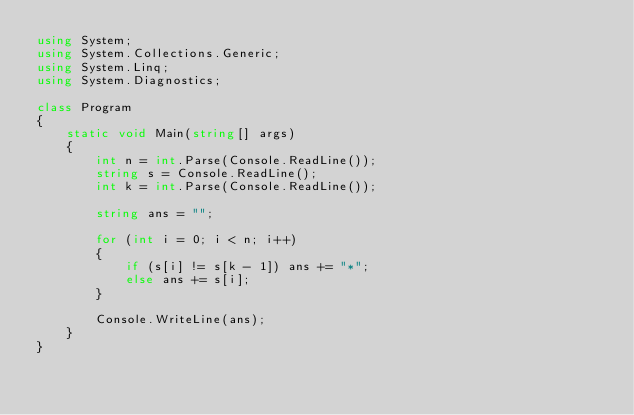<code> <loc_0><loc_0><loc_500><loc_500><_C#_>using System;
using System.Collections.Generic;
using System.Linq;
using System.Diagnostics;

class Program
{
    static void Main(string[] args)
    {
        int n = int.Parse(Console.ReadLine());
        string s = Console.ReadLine();
        int k = int.Parse(Console.ReadLine());

        string ans = "";

        for (int i = 0; i < n; i++)
        {
            if (s[i] != s[k - 1]) ans += "*";
            else ans += s[i];
        }

        Console.WriteLine(ans);
    }
}</code> 